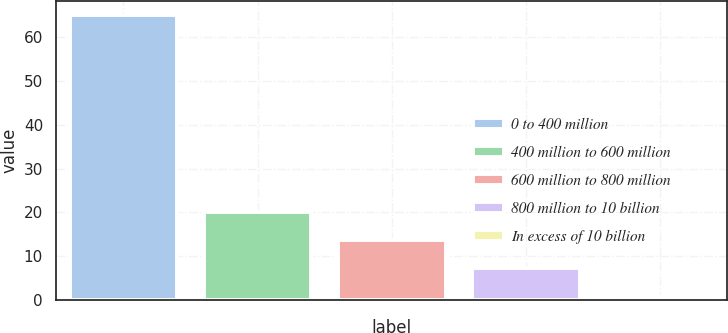<chart> <loc_0><loc_0><loc_500><loc_500><bar_chart><fcel>0 to 400 million<fcel>400 million to 600 million<fcel>600 million to 800 million<fcel>800 million to 10 billion<fcel>In excess of 10 billion<nl><fcel>65<fcel>20.2<fcel>13.8<fcel>7.4<fcel>1<nl></chart> 